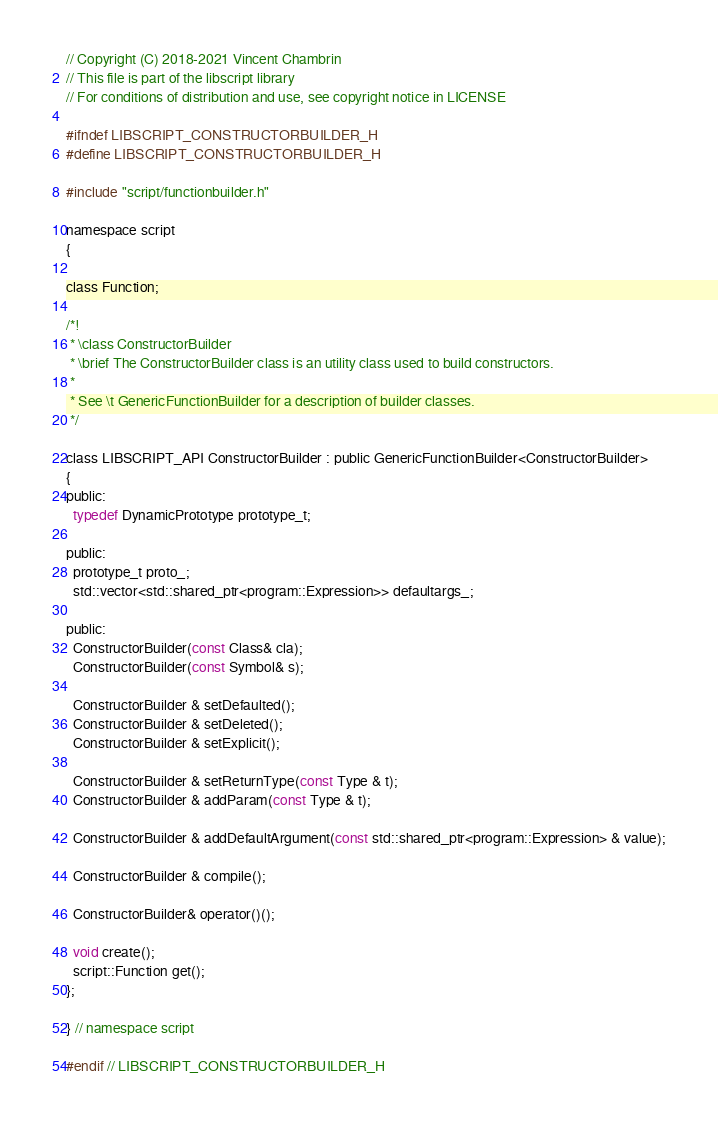<code> <loc_0><loc_0><loc_500><loc_500><_C_>// Copyright (C) 2018-2021 Vincent Chambrin
// This file is part of the libscript library
// For conditions of distribution and use, see copyright notice in LICENSE

#ifndef LIBSCRIPT_CONSTRUCTORBUILDER_H
#define LIBSCRIPT_CONSTRUCTORBUILDER_H

#include "script/functionbuilder.h"

namespace script
{

class Function;

/*!
 * \class ConstructorBuilder
 * \brief The ConstructorBuilder class is an utility class used to build constructors.
 *
 * See \t GenericFunctionBuilder for a description of builder classes.
 */

class LIBSCRIPT_API ConstructorBuilder : public GenericFunctionBuilder<ConstructorBuilder>
{
public:
  typedef DynamicPrototype prototype_t;

public:
  prototype_t proto_;
  std::vector<std::shared_ptr<program::Expression>> defaultargs_;

public:
  ConstructorBuilder(const Class& cla);
  ConstructorBuilder(const Symbol& s);

  ConstructorBuilder & setDefaulted();
  ConstructorBuilder & setDeleted();
  ConstructorBuilder & setExplicit();

  ConstructorBuilder & setReturnType(const Type & t);
  ConstructorBuilder & addParam(const Type & t);

  ConstructorBuilder & addDefaultArgument(const std::shared_ptr<program::Expression> & value);

  ConstructorBuilder & compile();

  ConstructorBuilder& operator()();

  void create();
  script::Function get();
};

} // namespace script

#endif // LIBSCRIPT_CONSTRUCTORBUILDER_H
</code> 